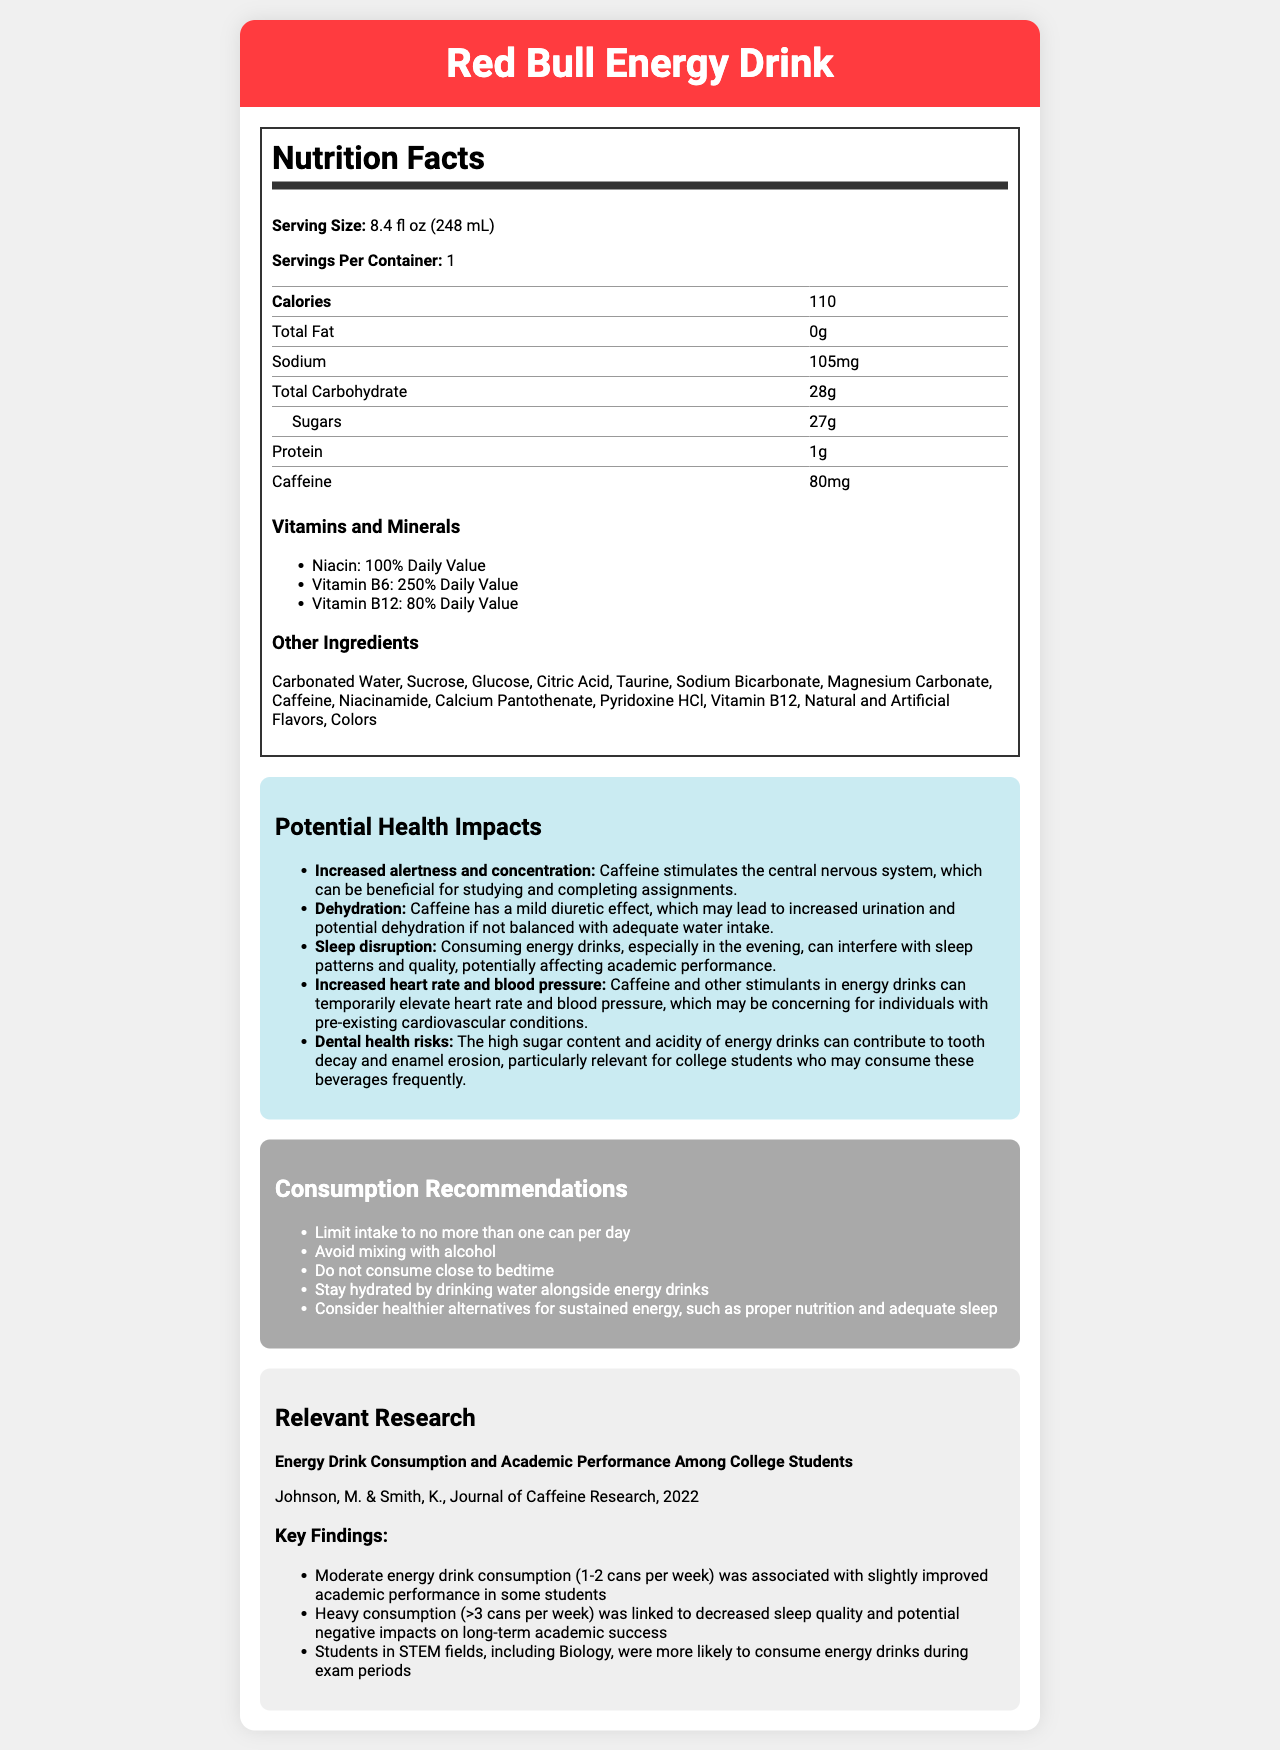what is the serving size of Red Bull Energy Drink? The serving size is listed at the beginning of the Nutrition Facts section: "Serving Size: 8.4 fl oz (248 mL)."
Answer: 8.4 fl oz (248 mL) how many calories are in one serving of Red Bull Energy Drink? The number of calories in one serving is listed in the Nutrition Facts section: "Calories 110."
Answer: 110 how much caffeine is in one can of Red Bull Energy Drink? The amount of caffeine per serving is listed in the Nutrition Facts section: "Caffeine 80mg."
Answer: 80mg what is the total carbohydrate content per serving? The total carbohydrate content is listed in the Nutrition Facts section: "Total Carbohydrate 28g."
Answer: 28g list two vitamins present in Red Bull Energy Drink and their daily values. The vitamins and their daily values are listed under the "Vitamins and Minerals" section in the Nutrition Facts: "Niacin: 100% Daily Value" and "Vitamin B6: 250% Daily Value."
Answer: Niacin: 100%, Vitamin B6: 250% what is one potential health impact of consuming Red Bull Energy Drink related to hydration? A. Increased hunger B. Dehydration C. Improved digestion D. Better sleep Under the "Potential Health Impacts" section, dehydration is listed as a potential health impact: "Caffeine has a mild diuretic effect, which may lead to increased urination and potential dehydration if not balanced with adequate water intake."
Answer: B. Dehydration which of the following is NOT an ingredient in Red Bull Energy Drink? 1. Taurine 2. Aspartame 3. Magnesium Carbonate 4. Glucose Aspartame is not listed under the Other Ingredients section, unlike Taurine, Magnesium Carbonate, and Glucose.
Answer: 2. Aspartame can consuming Red Bull Energy Drink in the evening affect sleep? The document states in the Potential Health Impacts section that consuming energy drinks in the evening can interfere with sleep patterns and quality: "Consuming energy drinks, especially in the evening, can interfere with sleep patterns and quality."
Answer: Yes how many grams of sugar are in one can of Red Bull Energy Drink? The sugar content is listed under the Total Carbohydrate section in the Nutrition Facts: "Sugars 27g."
Answer: 27g why might college students, especially in STEM fields, consume energy drinks like Red Bull during exam periods? The document states that caffeine stimulates the central nervous system, which can be beneficial for studying and completing assignments. Additionally, research indicates that students in STEM fields are more likely to consume energy drinks during exam periods for improved academic performance.
Answer: For increased alertness and concentration what is one recommendation for consuming Red Bull Energy Drink to prevent dehydration? The document recommends staying hydrated by drinking water alongside energy drinks to counteract the diuretic effects of caffeine.
Answer: Stay hydrated by drinking water alongside energy drinks summarize the main idea of the document. The document focuses on presenting comprehensive details about Red Bull Energy Drink, covering nutritional facts, ingredients, potential health implications, consumption guidelines, and research on academic performance, to inform and guide consumers, particularly college students.
Answer: The document provides detailed information about the nutritional content, ingredients, health impacts, consumption recommendations, and relevant research findings regarding Red Bull Energy Drink. It highlights caffeine content, potential impacts such as increased alertness and dehydration, and advises on responsible consumption. what is the name of the journal where the relevant research on energy drinks and academic performance was published? The journal name is stated in the Relevant Research section: "Journal of Caffeine Research."
Answer: Journal of Caffeine Research how does heavy consumption of energy drinks affect long-term academic success? The Relevant Research section specifies that heavy consumption (>3 cans per week) is linked to decreased sleep quality and potential negative impacts on long-term academic success.
Answer: Decreases sleep quality and potentially negative impacts academic success what type of flavors are included in Red Bull Energy Drink? The Other Ingredients section lists "Natural and Artificial Flavors" among the components of the drink.
Answer: Natural and Artificial Flavors what is the maximum recommended daily consumption of Red Bull Energy Drink? The Consumption Recommendations section advises to "Limit intake to no more than one can per day."
Answer: No more than one can per day which ingredient gives a diuretic effect, potentially leading to dehydration? The Potential Health Impacts section explains that caffeine has a mild diuretic effect, which may lead to dehydration if not balanced with adequate water intake.
Answer: Caffeine what are the key findings of the research study on energy drink consumption and academic performance among college students? The Relevant Research section details three key findings: 1) Moderate consumption (1-2 cans per week) slightly improves performance, 2) Heavy consumption (>3 cans per week) decreases sleep quality and affects long-term success, 3) STEM students are more likely to consume during exams.
Answer: Moderate consumption is linked to slightly improved performance, heavy consumption affects sleep quality and long-term success, and STEM students are more likely to consume during exams. how does the consumption of Red Bull Energy Drink specifically benefit college students during study sessions? The document states that caffeine stimulates the central nervous system, enhancing alertness and concentration, which can benefit students during study sessions.
Answer: Increases alertness and concentration how much protein is in one serving of Red Bull Energy Drink? The protein content per serving is listed in the Nutrition Facts section: "Protein 1g."
Answer: 1g what is the impact of mixing Red Bull Energy Drink with alcohol according to the recommendations? The recommendations section advises to "Avoid mixing with alcohol" but does not specify the impact.
Answer: Not specified in the document 